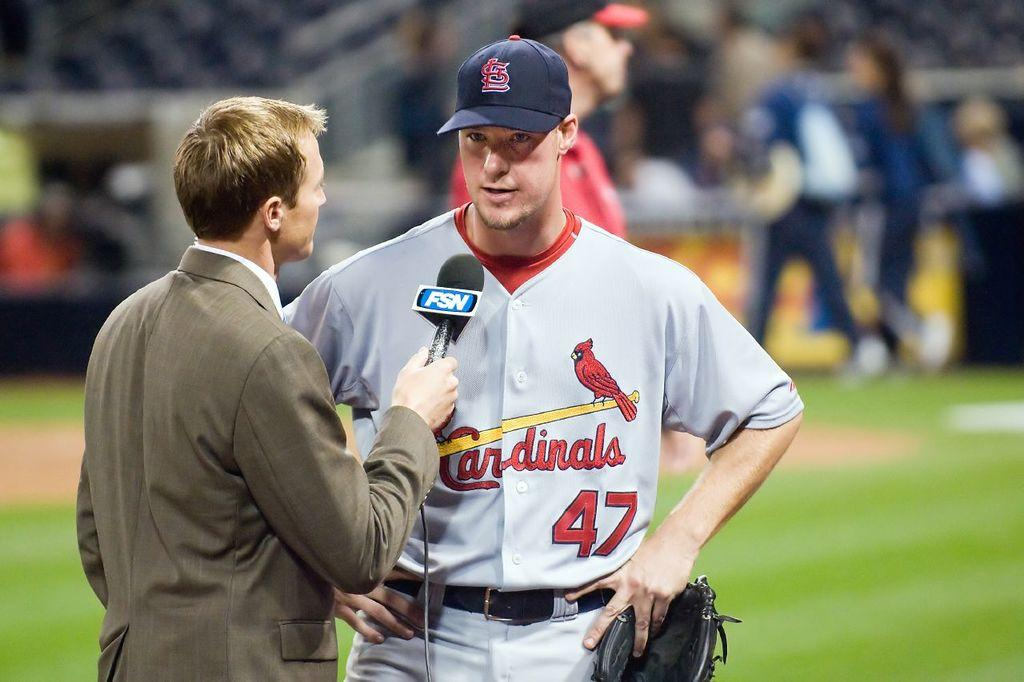<image>
Share a concise interpretation of the image provided. Number 47 is being interviewed by a reporter on FSN. 